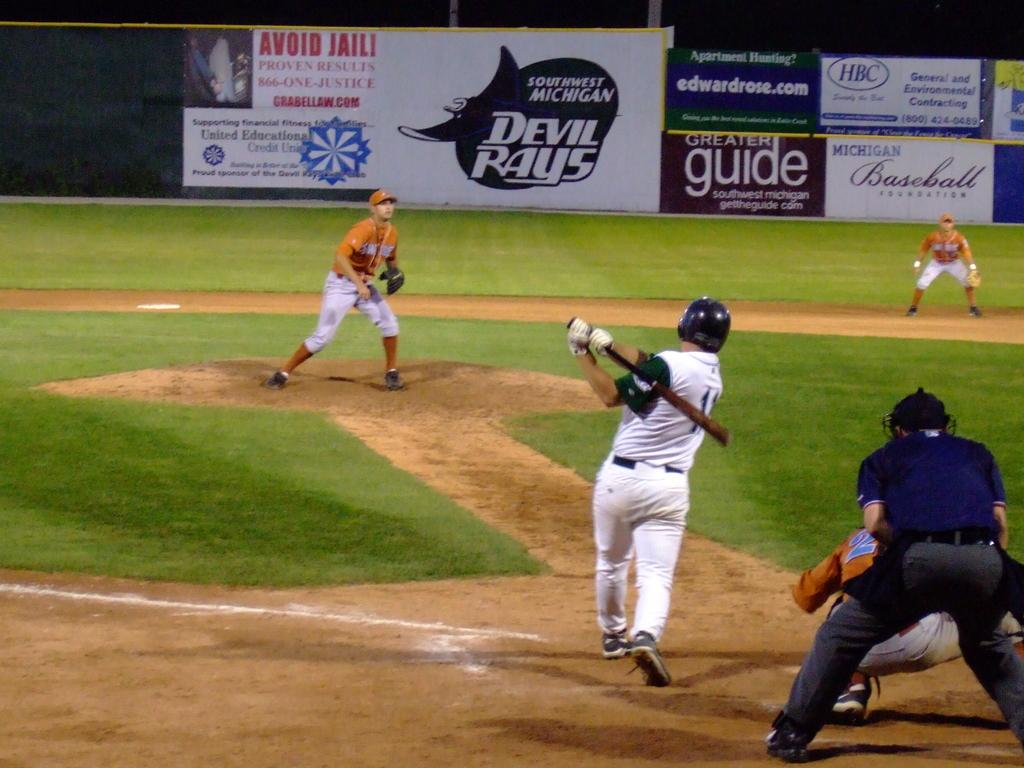<image>
Create a compact narrative representing the image presented. A baseball game is being played at the Devil Rays baseball field. 